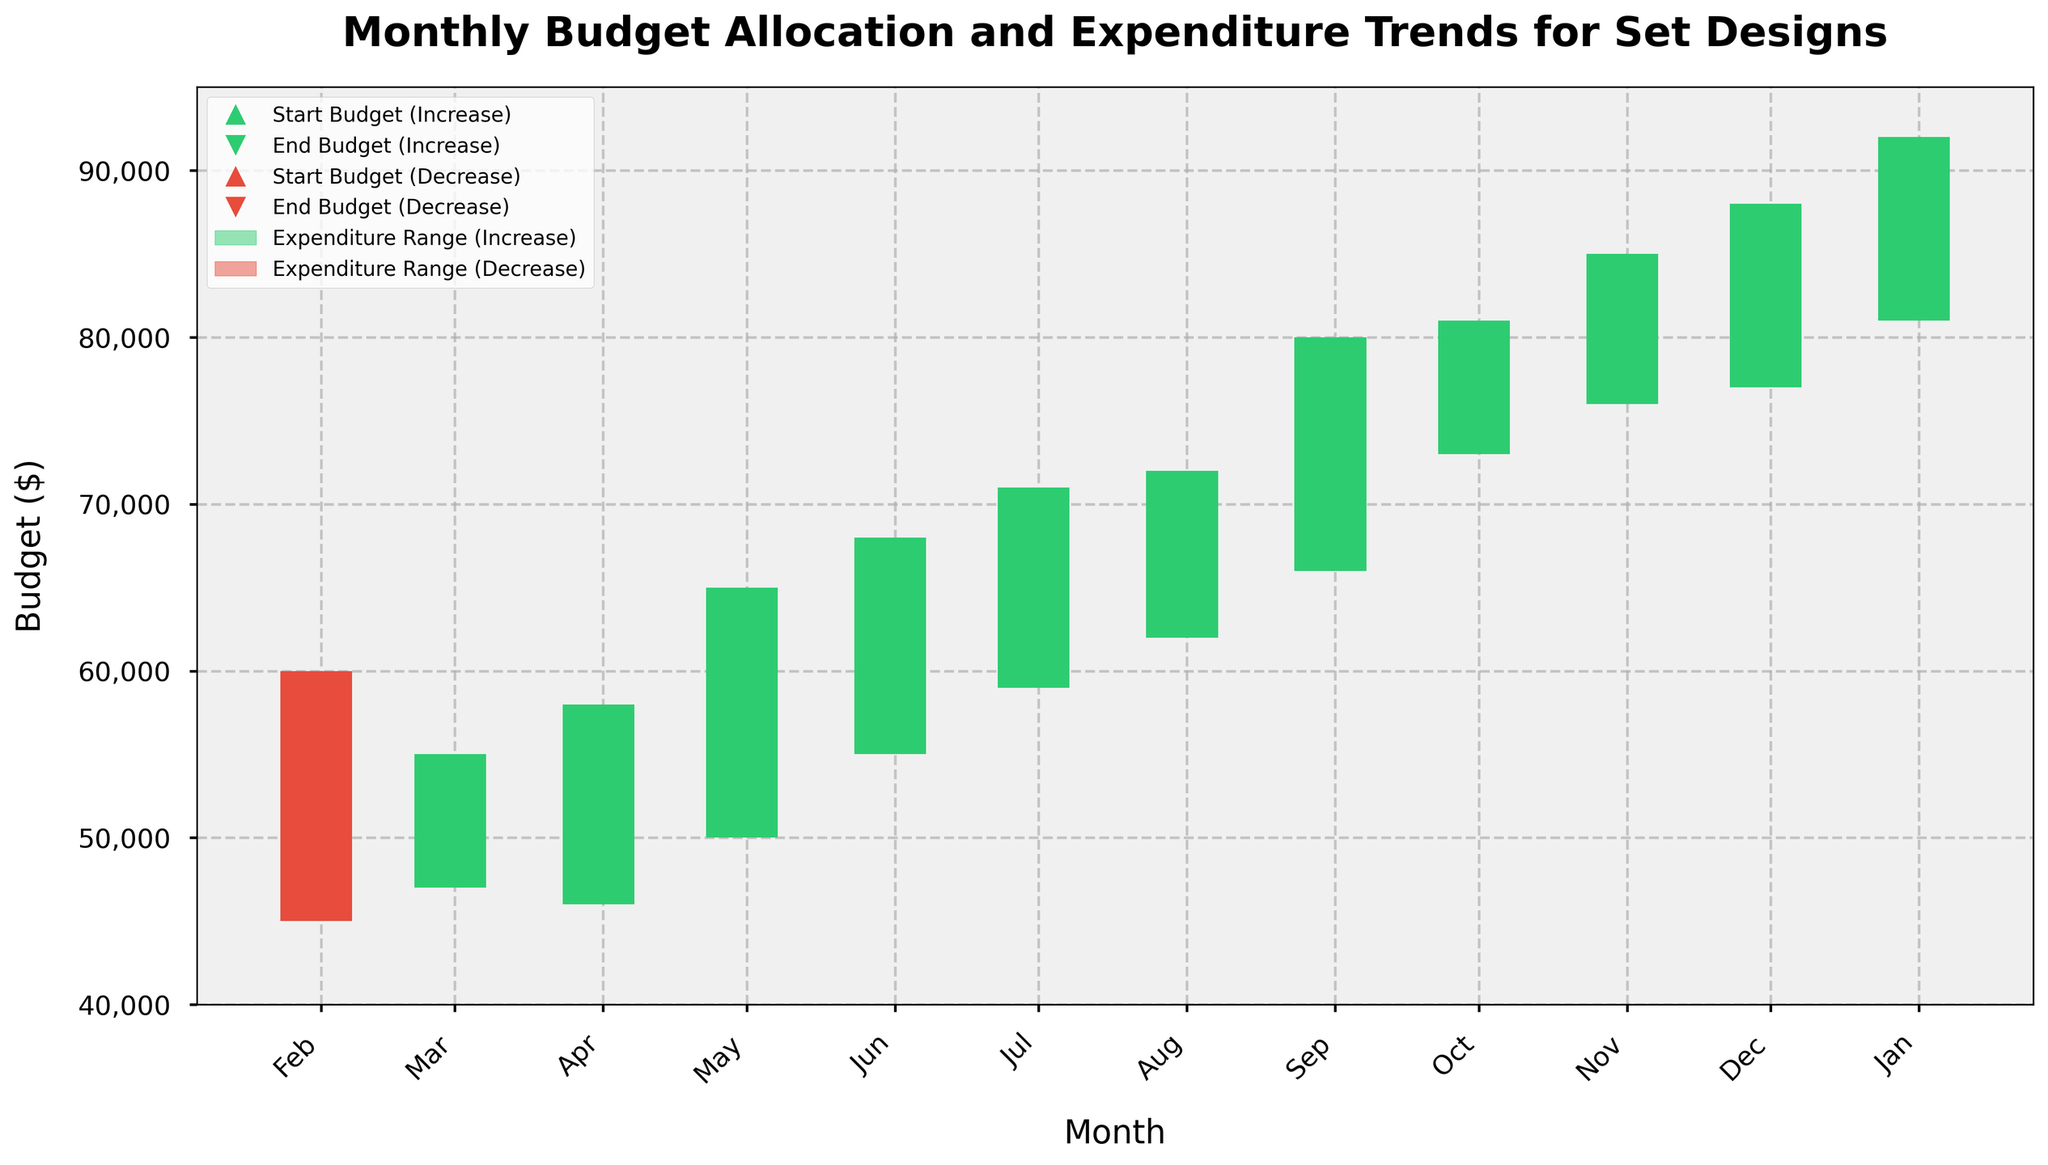What is the title of the figure? The title is usually displayed at the top of the figure. In this case, it should be a prominent, bold text.
Answer: Monthly Budget Allocation and Expenditure Trends for Set Designs What does the green color represent in this chart? The green color is associated with periods where the End Budget is higher than the Start Budget. It is used in the bars representing expenditure ranges and the markers for Start and End Budgets.
Answer: Increase in Budget In which months did the End Budget exceed the Start Budget? Look for the green markers at the top of the vertical lines. These indicate months where the End Budget is greater than the Start Budget.
Answer: April to December Which month shows the highest expenditure range? The expenditure range is represented by the height of the bars. The tallest bar indicates the highest expenditure range.
Answer: August What is the overall trend in the End Budget from January to December? Observe the bottom markers (End Budget) across all months. Describe the progression from January to December.
Answer: Increasing What are the Start and End Budgets for June? Locate the green or red markers at the start and end of the vertical line for June. Read their values from the Y-axis.
Answer: Start: 62,000; End: 65,000 How many months had decreased budgets? Count the red markers at the top of the vertical lines, which are the markers representing months with a decreased budget.
Answer: Three (January, February, March) During which month did the lowest expenditure occur, and what was its value? Look for the lowest point of the vertical lines, which represents the Low Expenditure value. Identify the corresponding month and value.
Answer: March; 46,000 Compare the High Expenditure values between February and November. Which is higher and by how much? Find the High Expenditure values for February and November on the Y-axis. Subtract the smaller value from the larger one.
Answer: November is higher by 33,000 (88,000 - 55,000) What is the average Start Budget for the entire year? Sum the Start Budgets for all months and divide by the number of months (12).
Answer: 64,083.33 